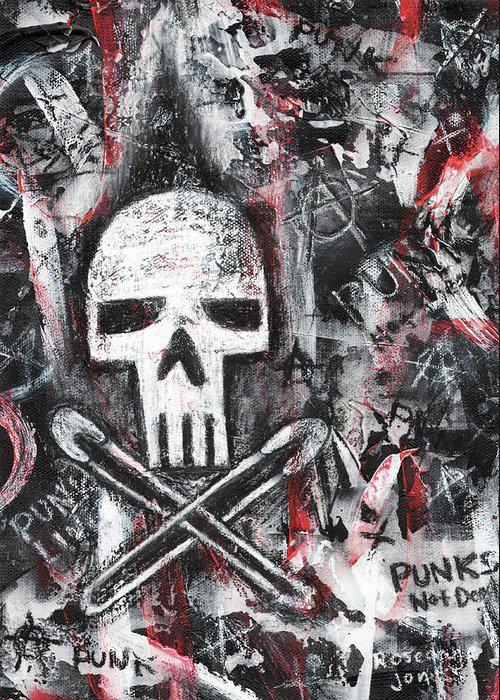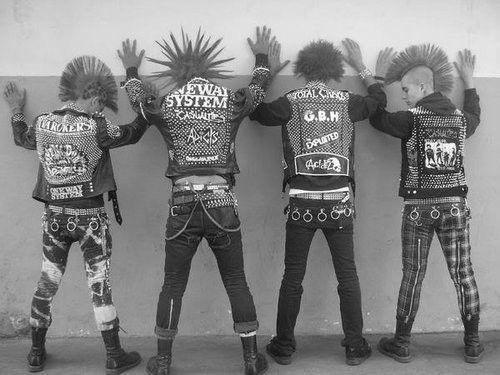The first image is the image on the left, the second image is the image on the right. Given the left and right images, does the statement "The left image includes some depiction of safety pins, and the right image features at least one spike-studded leather jacket." hold true? Answer yes or no. Yes. The first image is the image on the left, the second image is the image on the right. For the images shown, is this caption "One of the images features a jacket held together with several safety pins." true? Answer yes or no. No. 